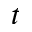<formula> <loc_0><loc_0><loc_500><loc_500>t</formula> 